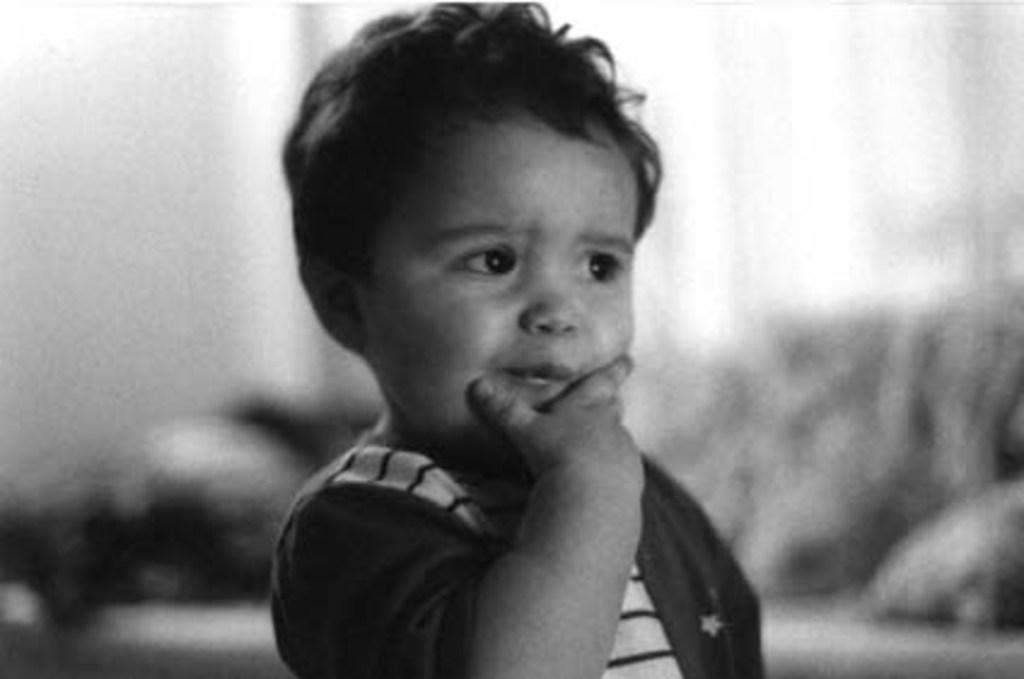What is the color scheme of the image? The image is black and white. Who or what is the main subject in the image? There is a boy in the image. What is the boy wearing? The boy is wearing a T-shirt. Can you describe the background of the image? The background of the image appears blurry. Can you see a giraffe carrying a tray on a railway in the image? No, there is no giraffe, tray, or railway present in the image. 